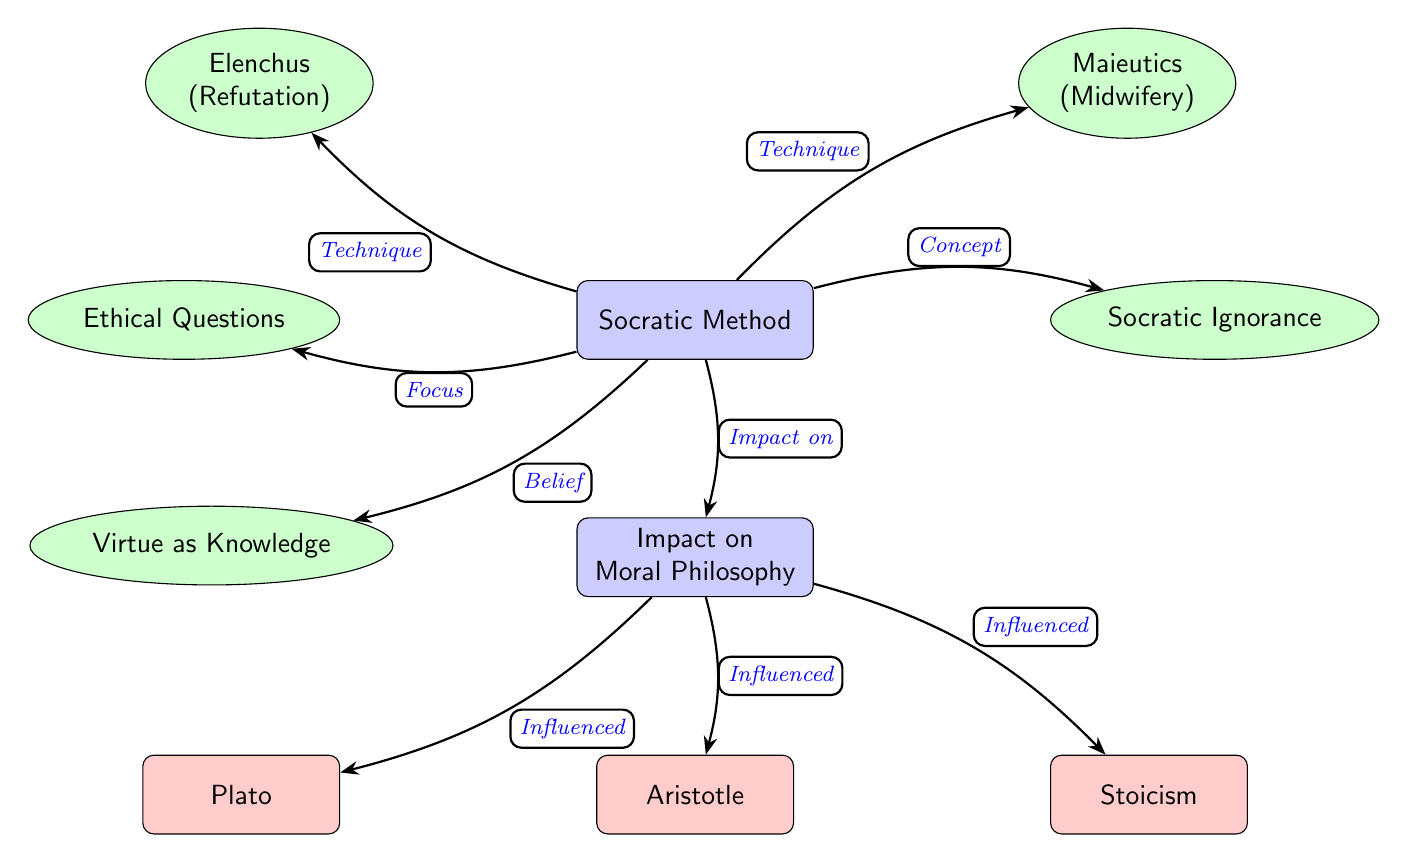What is the primary technique of the Socratic Method? The diagram identifies "Elenchus (Refutation)" and "Maieutics (Midwifery)" as techniques used in the Socratic Method. However, since the question specifically refers to the primary technique, we focus on the first mentioned technique, which is Elenchus.
Answer: Elenchus Which concept does the Socratic Method focus on? The diagram shows that the Socratic Method focuses on "Ethical Questions," which is directly connected to it. This indicates that the primary area of inquiry for the Socratic Method is ethical dilemmas or moral questions.
Answer: Ethical Questions How many influences are listed regarding the impact on moral philosophy? By counting the nodes below the "Impact on Moral Philosophy" node, we find three influences: "Plato," "Aristotle," and "Stoicism." This gives a total of three influences.
Answer: 3 What is the connection between the Socratic Method and Socratic Ignorance? The diagram establishes a relationship where the Socratic Method affects or is related to "Socratic Ignorance," indicating that a core belief of Socrates was recognizing one’s own ignorance. This relationship is labeled "Concept."
Answer: Concept Which philosophical figure is influenced by the impact on moral philosophy represented in the diagram? The diagram indicates that "Plato," "Aristotle," and "Stoicism" are all influenced by the impact on moral philosophy. The first figure listed that is influenced is Plato.
Answer: Plato What does Socratic ignorance denote in this diagram? "Socratic Ignorance" is connected to the Socratic Method and reflects a key belief that knowledge begins with acknowledging one's ignorance. This idea aligns closely with Socratic questioning.
Answer: Belief Describe the relationship between the Socratic Method and Ethical Questions. There is a directed connection from the "Socratic Method" to "Ethical Questions," labeled as "Focus." This suggests that the key focus or application of the Socratic Method is exploring ethical questions.
Answer: Focus Which technique is primarily associated with a midwifery approach in the Socratic Method? The diagram notes that "Maieutics (Midwifery)" is one of the techniques of the Socratic Method, where the approach is to bring forth knowledge from within the individual, similar to a midwife assisting in childbirth.
Answer: Maieutics 